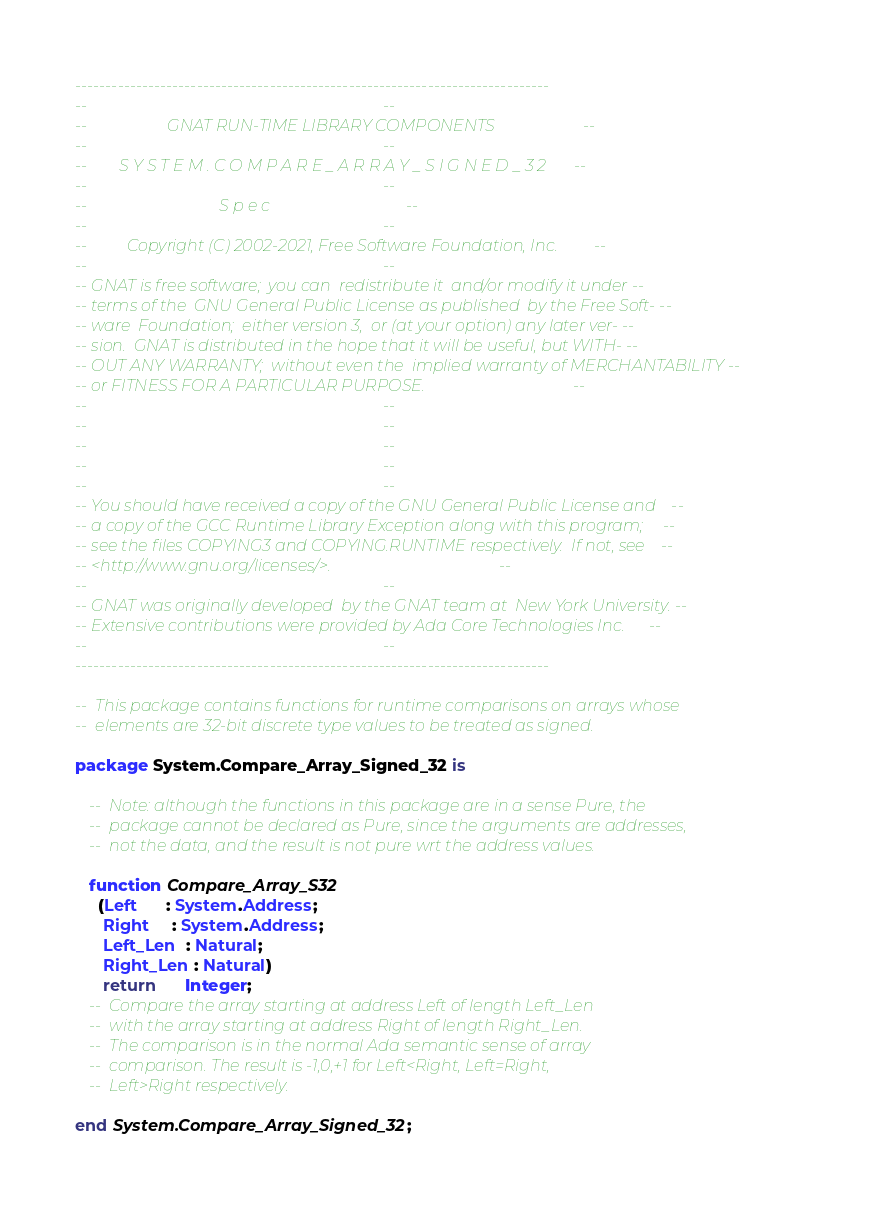Convert code to text. <code><loc_0><loc_0><loc_500><loc_500><_Ada_>------------------------------------------------------------------------------
--                                                                          --
--                    GNAT RUN-TIME LIBRARY COMPONENTS                      --
--                                                                          --
--        S Y S T E M . C O M P A R E _ A R R A Y _ S I G N E D _ 3 2       --
--                                                                          --
--                                 S p e c                                  --
--                                                                          --
--          Copyright (C) 2002-2021, Free Software Foundation, Inc.         --
--                                                                          --
-- GNAT is free software;  you can  redistribute it  and/or modify it under --
-- terms of the  GNU General Public License as published  by the Free Soft- --
-- ware  Foundation;  either version 3,  or (at your option) any later ver- --
-- sion.  GNAT is distributed in the hope that it will be useful, but WITH- --
-- OUT ANY WARRANTY;  without even the  implied warranty of MERCHANTABILITY --
-- or FITNESS FOR A PARTICULAR PURPOSE.                                     --
--                                                                          --
--                                                                          --
--                                                                          --
--                                                                          --
--                                                                          --
-- You should have received a copy of the GNU General Public License and    --
-- a copy of the GCC Runtime Library Exception along with this program;     --
-- see the files COPYING3 and COPYING.RUNTIME respectively.  If not, see    --
-- <http://www.gnu.org/licenses/>.                                          --
--                                                                          --
-- GNAT was originally developed  by the GNAT team at  New York University. --
-- Extensive contributions were provided by Ada Core Technologies Inc.      --
--                                                                          --
------------------------------------------------------------------------------

--  This package contains functions for runtime comparisons on arrays whose
--  elements are 32-bit discrete type values to be treated as signed.

package System.Compare_Array_Signed_32 is

   --  Note: although the functions in this package are in a sense Pure, the
   --  package cannot be declared as Pure, since the arguments are addresses,
   --  not the data, and the result is not pure wrt the address values.

   function Compare_Array_S32
     (Left      : System.Address;
      Right     : System.Address;
      Left_Len  : Natural;
      Right_Len : Natural)
      return      Integer;
   --  Compare the array starting at address Left of length Left_Len
   --  with the array starting at address Right of length Right_Len.
   --  The comparison is in the normal Ada semantic sense of array
   --  comparison. The result is -1,0,+1 for Left<Right, Left=Right,
   --  Left>Right respectively.

end System.Compare_Array_Signed_32;
</code> 